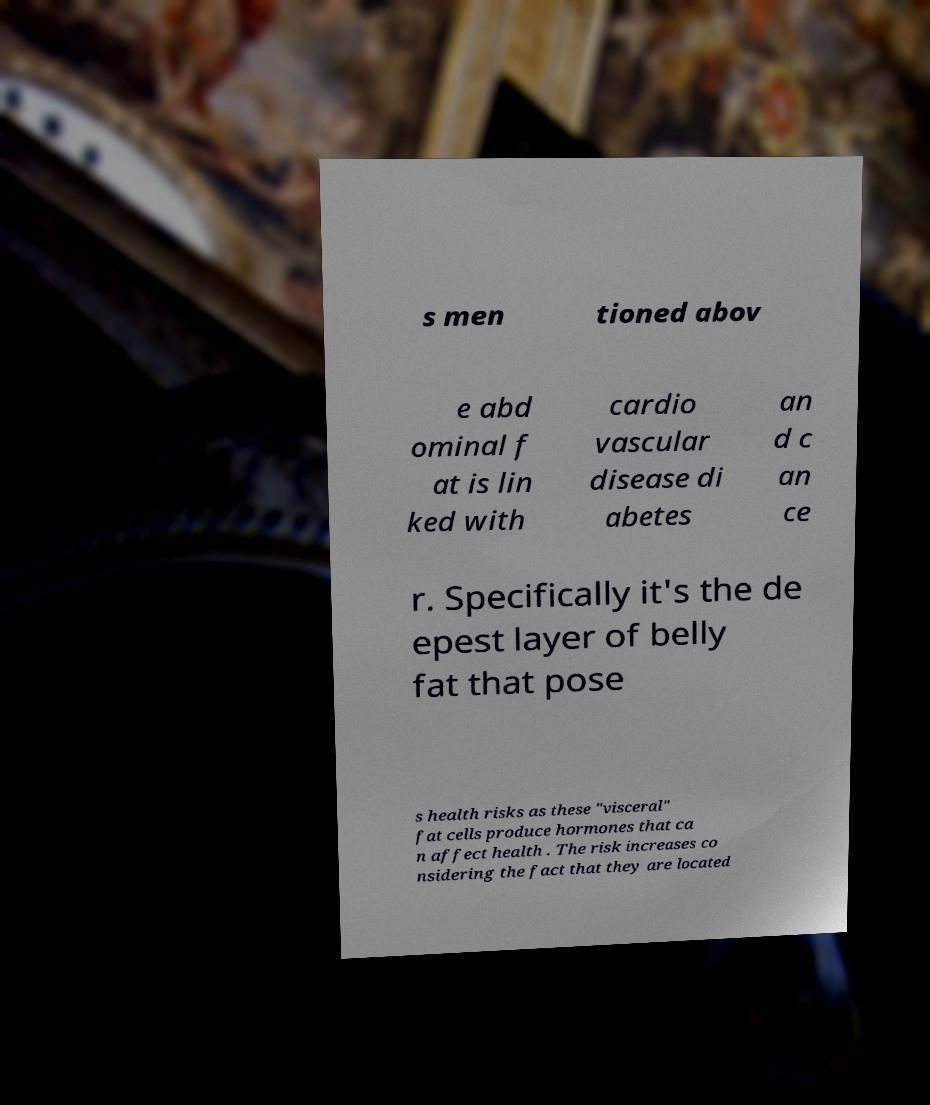Please identify and transcribe the text found in this image. s men tioned abov e abd ominal f at is lin ked with cardio vascular disease di abetes an d c an ce r. Specifically it's the de epest layer of belly fat that pose s health risks as these "visceral" fat cells produce hormones that ca n affect health . The risk increases co nsidering the fact that they are located 